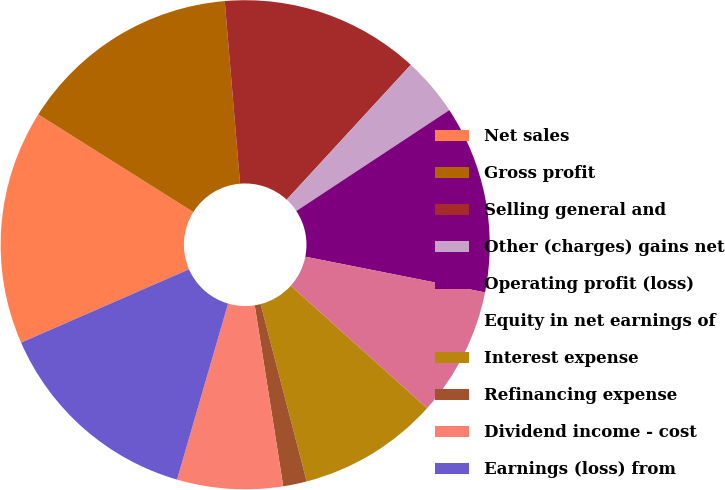Convert chart to OTSL. <chart><loc_0><loc_0><loc_500><loc_500><pie_chart><fcel>Net sales<fcel>Gross profit<fcel>Selling general and<fcel>Other (charges) gains net<fcel>Operating profit (loss)<fcel>Equity in net earnings of<fcel>Interest expense<fcel>Refinancing expense<fcel>Dividend income - cost<fcel>Earnings (loss) from<nl><fcel>15.5%<fcel>14.72%<fcel>13.17%<fcel>3.88%<fcel>12.4%<fcel>8.53%<fcel>9.3%<fcel>1.56%<fcel>6.98%<fcel>13.95%<nl></chart> 